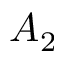Convert formula to latex. <formula><loc_0><loc_0><loc_500><loc_500>A _ { 2 }</formula> 